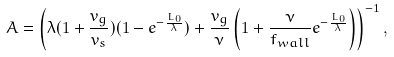<formula> <loc_0><loc_0><loc_500><loc_500>A = \left ( \lambda ( 1 + \frac { v _ { g } } { v _ { s } } ) ( 1 - e ^ { - \frac { L _ { 0 } } { \lambda } } ) + \frac { v _ { g } } { \nu } \left ( 1 + \frac { \nu } { f _ { w a l l } } e ^ { - \frac { L _ { 0 } } { \lambda } } \right ) \right ) ^ { - 1 } ,</formula> 